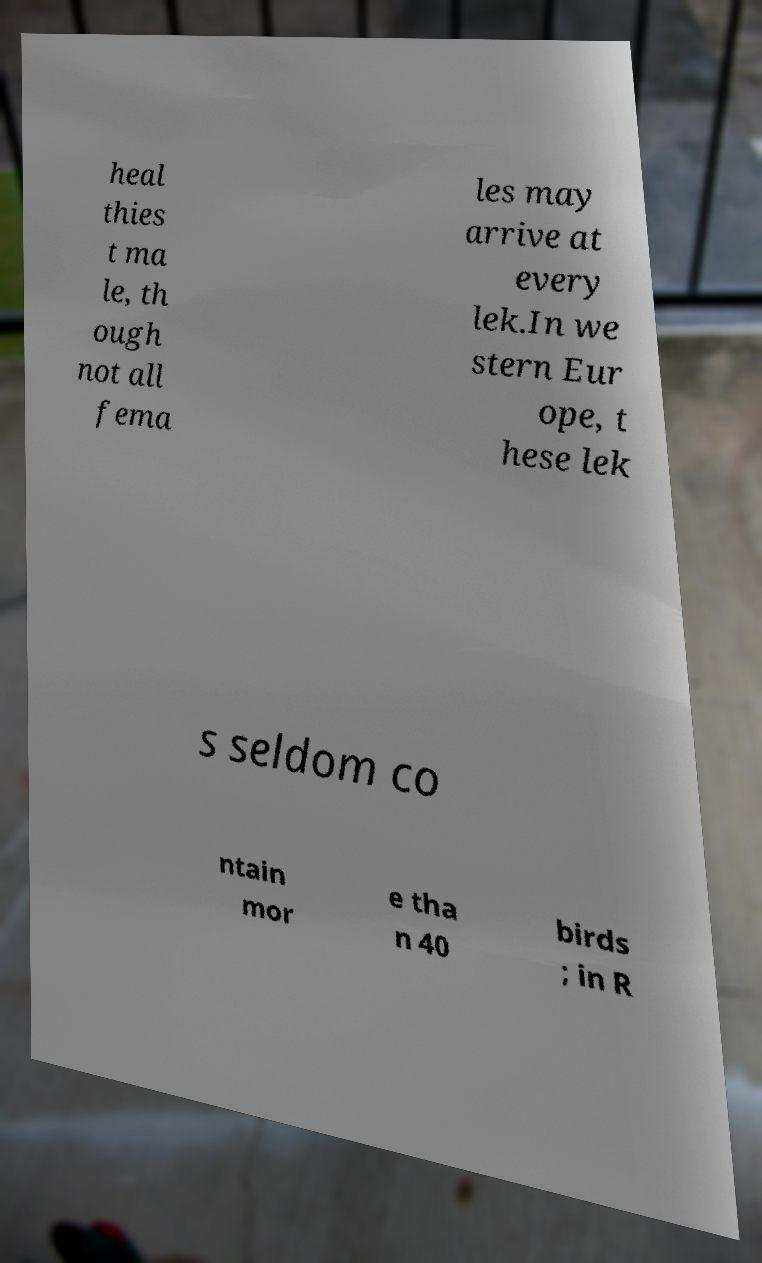Could you assist in decoding the text presented in this image and type it out clearly? heal thies t ma le, th ough not all fema les may arrive at every lek.In we stern Eur ope, t hese lek s seldom co ntain mor e tha n 40 birds ; in R 